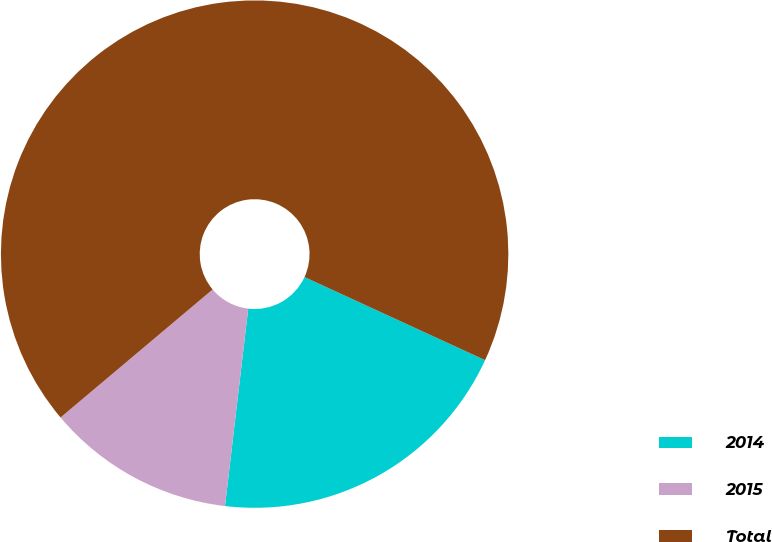<chart> <loc_0><loc_0><loc_500><loc_500><pie_chart><fcel>2014<fcel>2015<fcel>Total<nl><fcel>20.0%<fcel>12.0%<fcel>68.0%<nl></chart> 